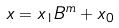Convert formula to latex. <formula><loc_0><loc_0><loc_500><loc_500>x = x _ { 1 } B ^ { m } + x _ { 0 }</formula> 